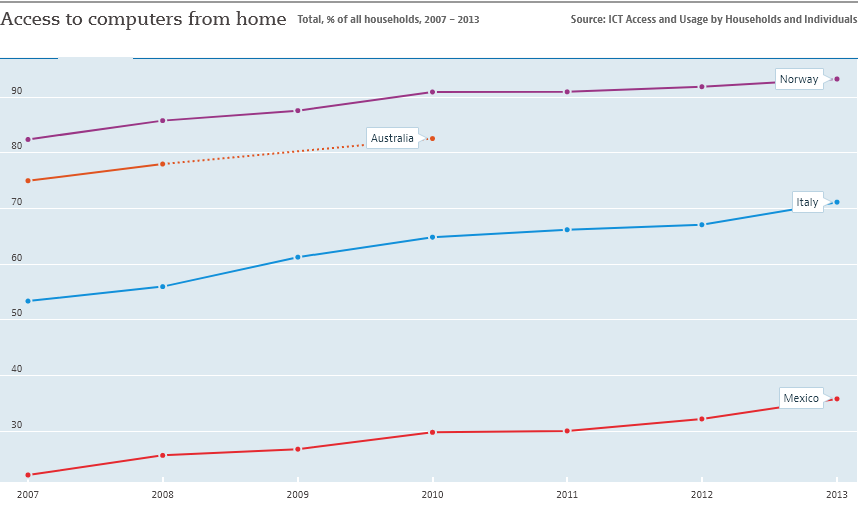Which country has the least access to computers from home? Based on the graph provided, it appears that Mexico has the least access to computers from home among the countries shown, with less than 40% of households having access in 2013. It's important to note, though, that the data is limited to the countries depicted and the years 2007 to 2013. For a more current or global perspective, additional data would need to be consulted. 